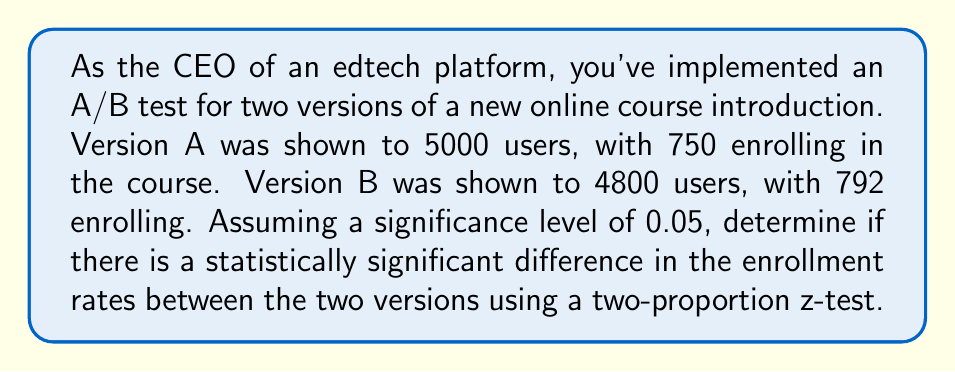Could you help me with this problem? To analyze the A/B test results, we'll use a two-proportion z-test. Let's follow these steps:

1. Define null and alternative hypotheses:
   $H_0: p_A = p_B$ (no difference in proportions)
   $H_a: p_A \neq p_B$ (there is a difference in proportions)

2. Calculate the sample proportions:
   $\hat{p}_A = \frac{750}{5000} = 0.15$
   $\hat{p}_B = \frac{792}{4800} = 0.165$

3. Calculate the pooled proportion:
   $$\hat{p} = \frac{X_A + X_B}{n_A + n_B} = \frac{750 + 792}{5000 + 4800} = \frac{1542}{9800} = 0.15735$$

4. Calculate the standard error:
   $$SE = \sqrt{\hat{p}(1-\hat{p})(\frac{1}{n_A} + \frac{1}{n_B})}$$
   $$SE = \sqrt{0.15735(1-0.15735)(\frac{1}{5000} + \frac{1}{4800})} = 0.00731$$

5. Calculate the z-statistic:
   $$z = \frac{\hat{p}_A - \hat{p}_B}{SE} = \frac{0.15 - 0.165}{0.00731} = -2.052$$

6. Find the critical value:
   For a two-tailed test with α = 0.05, the critical value is ±1.96.

7. Compare the z-statistic to the critical value:
   |-2.052| > 1.96, so we reject the null hypothesis.

8. Calculate the p-value:
   p-value = 2 * P(Z < -2.052) = 2 * 0.0201 = 0.0402

Since the p-value (0.0402) is less than the significance level (0.05), we reject the null hypothesis and conclude that there is a statistically significant difference in enrollment rates between the two versions.
Answer: Reject $H_0$; significant difference (p-value = 0.0402) 